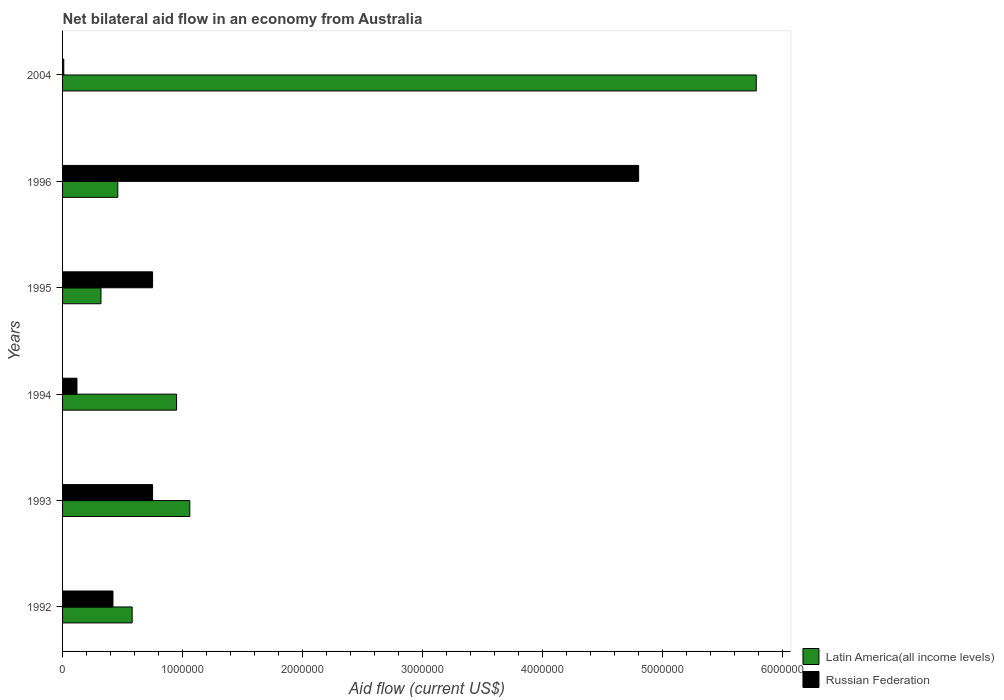How many different coloured bars are there?
Your response must be concise. 2. Are the number of bars per tick equal to the number of legend labels?
Provide a short and direct response. Yes. Are the number of bars on each tick of the Y-axis equal?
Ensure brevity in your answer.  Yes. How many bars are there on the 3rd tick from the top?
Your answer should be compact. 2. How many bars are there on the 3rd tick from the bottom?
Your response must be concise. 2. What is the label of the 1st group of bars from the top?
Provide a succinct answer. 2004. In how many cases, is the number of bars for a given year not equal to the number of legend labels?
Your answer should be compact. 0. What is the net bilateral aid flow in Russian Federation in 1992?
Make the answer very short. 4.20e+05. Across all years, what is the maximum net bilateral aid flow in Russian Federation?
Offer a terse response. 4.80e+06. Across all years, what is the minimum net bilateral aid flow in Latin America(all income levels)?
Offer a terse response. 3.20e+05. In which year was the net bilateral aid flow in Latin America(all income levels) minimum?
Keep it short and to the point. 1995. What is the total net bilateral aid flow in Russian Federation in the graph?
Make the answer very short. 6.85e+06. What is the difference between the net bilateral aid flow in Russian Federation in 1993 and that in 1994?
Your answer should be compact. 6.30e+05. What is the difference between the net bilateral aid flow in Latin America(all income levels) in 1993 and the net bilateral aid flow in Russian Federation in 1992?
Ensure brevity in your answer.  6.40e+05. What is the average net bilateral aid flow in Russian Federation per year?
Offer a very short reply. 1.14e+06. In the year 1996, what is the difference between the net bilateral aid flow in Russian Federation and net bilateral aid flow in Latin America(all income levels)?
Provide a short and direct response. 4.34e+06. What is the ratio of the net bilateral aid flow in Latin America(all income levels) in 1994 to that in 1995?
Give a very brief answer. 2.97. Is the net bilateral aid flow in Russian Federation in 1993 less than that in 1994?
Offer a terse response. No. Is the difference between the net bilateral aid flow in Russian Federation in 1995 and 1996 greater than the difference between the net bilateral aid flow in Latin America(all income levels) in 1995 and 1996?
Offer a very short reply. No. What is the difference between the highest and the second highest net bilateral aid flow in Latin America(all income levels)?
Offer a terse response. 4.72e+06. What is the difference between the highest and the lowest net bilateral aid flow in Latin America(all income levels)?
Make the answer very short. 5.46e+06. In how many years, is the net bilateral aid flow in Latin America(all income levels) greater than the average net bilateral aid flow in Latin America(all income levels) taken over all years?
Provide a short and direct response. 1. What does the 2nd bar from the top in 1992 represents?
Make the answer very short. Latin America(all income levels). What does the 1st bar from the bottom in 1994 represents?
Provide a short and direct response. Latin America(all income levels). How many bars are there?
Make the answer very short. 12. How many years are there in the graph?
Ensure brevity in your answer.  6. What is the difference between two consecutive major ticks on the X-axis?
Your answer should be very brief. 1.00e+06. Are the values on the major ticks of X-axis written in scientific E-notation?
Ensure brevity in your answer.  No. Does the graph contain any zero values?
Offer a terse response. No. Does the graph contain grids?
Your answer should be very brief. No. Where does the legend appear in the graph?
Make the answer very short. Bottom right. How many legend labels are there?
Make the answer very short. 2. What is the title of the graph?
Offer a terse response. Net bilateral aid flow in an economy from Australia. What is the label or title of the X-axis?
Make the answer very short. Aid flow (current US$). What is the Aid flow (current US$) of Latin America(all income levels) in 1992?
Provide a short and direct response. 5.80e+05. What is the Aid flow (current US$) of Russian Federation in 1992?
Make the answer very short. 4.20e+05. What is the Aid flow (current US$) in Latin America(all income levels) in 1993?
Give a very brief answer. 1.06e+06. What is the Aid flow (current US$) of Russian Federation in 1993?
Offer a terse response. 7.50e+05. What is the Aid flow (current US$) of Latin America(all income levels) in 1994?
Offer a terse response. 9.50e+05. What is the Aid flow (current US$) in Russian Federation in 1994?
Your answer should be compact. 1.20e+05. What is the Aid flow (current US$) of Russian Federation in 1995?
Make the answer very short. 7.50e+05. What is the Aid flow (current US$) of Latin America(all income levels) in 1996?
Your answer should be compact. 4.60e+05. What is the Aid flow (current US$) of Russian Federation in 1996?
Give a very brief answer. 4.80e+06. What is the Aid flow (current US$) of Latin America(all income levels) in 2004?
Provide a short and direct response. 5.78e+06. Across all years, what is the maximum Aid flow (current US$) in Latin America(all income levels)?
Provide a short and direct response. 5.78e+06. Across all years, what is the maximum Aid flow (current US$) of Russian Federation?
Your response must be concise. 4.80e+06. Across all years, what is the minimum Aid flow (current US$) in Latin America(all income levels)?
Give a very brief answer. 3.20e+05. Across all years, what is the minimum Aid flow (current US$) of Russian Federation?
Offer a very short reply. 10000. What is the total Aid flow (current US$) in Latin America(all income levels) in the graph?
Your answer should be very brief. 9.15e+06. What is the total Aid flow (current US$) of Russian Federation in the graph?
Provide a short and direct response. 6.85e+06. What is the difference between the Aid flow (current US$) of Latin America(all income levels) in 1992 and that in 1993?
Offer a very short reply. -4.80e+05. What is the difference between the Aid flow (current US$) in Russian Federation in 1992 and that in 1993?
Provide a succinct answer. -3.30e+05. What is the difference between the Aid flow (current US$) of Latin America(all income levels) in 1992 and that in 1994?
Offer a very short reply. -3.70e+05. What is the difference between the Aid flow (current US$) in Latin America(all income levels) in 1992 and that in 1995?
Offer a terse response. 2.60e+05. What is the difference between the Aid flow (current US$) in Russian Federation in 1992 and that in 1995?
Provide a short and direct response. -3.30e+05. What is the difference between the Aid flow (current US$) in Russian Federation in 1992 and that in 1996?
Give a very brief answer. -4.38e+06. What is the difference between the Aid flow (current US$) in Latin America(all income levels) in 1992 and that in 2004?
Give a very brief answer. -5.20e+06. What is the difference between the Aid flow (current US$) in Latin America(all income levels) in 1993 and that in 1994?
Keep it short and to the point. 1.10e+05. What is the difference between the Aid flow (current US$) of Russian Federation in 1993 and that in 1994?
Make the answer very short. 6.30e+05. What is the difference between the Aid flow (current US$) of Latin America(all income levels) in 1993 and that in 1995?
Ensure brevity in your answer.  7.40e+05. What is the difference between the Aid flow (current US$) of Russian Federation in 1993 and that in 1996?
Provide a short and direct response. -4.05e+06. What is the difference between the Aid flow (current US$) of Latin America(all income levels) in 1993 and that in 2004?
Your answer should be compact. -4.72e+06. What is the difference between the Aid flow (current US$) in Russian Federation in 1993 and that in 2004?
Your answer should be very brief. 7.40e+05. What is the difference between the Aid flow (current US$) in Latin America(all income levels) in 1994 and that in 1995?
Give a very brief answer. 6.30e+05. What is the difference between the Aid flow (current US$) in Russian Federation in 1994 and that in 1995?
Offer a very short reply. -6.30e+05. What is the difference between the Aid flow (current US$) of Russian Federation in 1994 and that in 1996?
Keep it short and to the point. -4.68e+06. What is the difference between the Aid flow (current US$) in Latin America(all income levels) in 1994 and that in 2004?
Provide a succinct answer. -4.83e+06. What is the difference between the Aid flow (current US$) of Russian Federation in 1994 and that in 2004?
Offer a very short reply. 1.10e+05. What is the difference between the Aid flow (current US$) in Russian Federation in 1995 and that in 1996?
Offer a terse response. -4.05e+06. What is the difference between the Aid flow (current US$) in Latin America(all income levels) in 1995 and that in 2004?
Your answer should be very brief. -5.46e+06. What is the difference between the Aid flow (current US$) of Russian Federation in 1995 and that in 2004?
Your response must be concise. 7.40e+05. What is the difference between the Aid flow (current US$) in Latin America(all income levels) in 1996 and that in 2004?
Your answer should be very brief. -5.32e+06. What is the difference between the Aid flow (current US$) of Russian Federation in 1996 and that in 2004?
Offer a terse response. 4.79e+06. What is the difference between the Aid flow (current US$) of Latin America(all income levels) in 1992 and the Aid flow (current US$) of Russian Federation in 1994?
Keep it short and to the point. 4.60e+05. What is the difference between the Aid flow (current US$) of Latin America(all income levels) in 1992 and the Aid flow (current US$) of Russian Federation in 1995?
Your answer should be very brief. -1.70e+05. What is the difference between the Aid flow (current US$) in Latin America(all income levels) in 1992 and the Aid flow (current US$) in Russian Federation in 1996?
Offer a very short reply. -4.22e+06. What is the difference between the Aid flow (current US$) in Latin America(all income levels) in 1992 and the Aid flow (current US$) in Russian Federation in 2004?
Make the answer very short. 5.70e+05. What is the difference between the Aid flow (current US$) of Latin America(all income levels) in 1993 and the Aid flow (current US$) of Russian Federation in 1994?
Give a very brief answer. 9.40e+05. What is the difference between the Aid flow (current US$) of Latin America(all income levels) in 1993 and the Aid flow (current US$) of Russian Federation in 1995?
Keep it short and to the point. 3.10e+05. What is the difference between the Aid flow (current US$) of Latin America(all income levels) in 1993 and the Aid flow (current US$) of Russian Federation in 1996?
Give a very brief answer. -3.74e+06. What is the difference between the Aid flow (current US$) of Latin America(all income levels) in 1993 and the Aid flow (current US$) of Russian Federation in 2004?
Your answer should be compact. 1.05e+06. What is the difference between the Aid flow (current US$) in Latin America(all income levels) in 1994 and the Aid flow (current US$) in Russian Federation in 1996?
Provide a succinct answer. -3.85e+06. What is the difference between the Aid flow (current US$) of Latin America(all income levels) in 1994 and the Aid flow (current US$) of Russian Federation in 2004?
Offer a very short reply. 9.40e+05. What is the difference between the Aid flow (current US$) in Latin America(all income levels) in 1995 and the Aid flow (current US$) in Russian Federation in 1996?
Offer a terse response. -4.48e+06. What is the difference between the Aid flow (current US$) in Latin America(all income levels) in 1995 and the Aid flow (current US$) in Russian Federation in 2004?
Offer a terse response. 3.10e+05. What is the difference between the Aid flow (current US$) in Latin America(all income levels) in 1996 and the Aid flow (current US$) in Russian Federation in 2004?
Your response must be concise. 4.50e+05. What is the average Aid flow (current US$) of Latin America(all income levels) per year?
Make the answer very short. 1.52e+06. What is the average Aid flow (current US$) in Russian Federation per year?
Provide a short and direct response. 1.14e+06. In the year 1992, what is the difference between the Aid flow (current US$) in Latin America(all income levels) and Aid flow (current US$) in Russian Federation?
Your answer should be compact. 1.60e+05. In the year 1993, what is the difference between the Aid flow (current US$) in Latin America(all income levels) and Aid flow (current US$) in Russian Federation?
Offer a terse response. 3.10e+05. In the year 1994, what is the difference between the Aid flow (current US$) of Latin America(all income levels) and Aid flow (current US$) of Russian Federation?
Offer a terse response. 8.30e+05. In the year 1995, what is the difference between the Aid flow (current US$) in Latin America(all income levels) and Aid flow (current US$) in Russian Federation?
Keep it short and to the point. -4.30e+05. In the year 1996, what is the difference between the Aid flow (current US$) in Latin America(all income levels) and Aid flow (current US$) in Russian Federation?
Your answer should be very brief. -4.34e+06. In the year 2004, what is the difference between the Aid flow (current US$) in Latin America(all income levels) and Aid flow (current US$) in Russian Federation?
Make the answer very short. 5.77e+06. What is the ratio of the Aid flow (current US$) in Latin America(all income levels) in 1992 to that in 1993?
Your response must be concise. 0.55. What is the ratio of the Aid flow (current US$) in Russian Federation in 1992 to that in 1993?
Ensure brevity in your answer.  0.56. What is the ratio of the Aid flow (current US$) of Latin America(all income levels) in 1992 to that in 1994?
Provide a short and direct response. 0.61. What is the ratio of the Aid flow (current US$) in Russian Federation in 1992 to that in 1994?
Your answer should be very brief. 3.5. What is the ratio of the Aid flow (current US$) of Latin America(all income levels) in 1992 to that in 1995?
Offer a very short reply. 1.81. What is the ratio of the Aid flow (current US$) of Russian Federation in 1992 to that in 1995?
Keep it short and to the point. 0.56. What is the ratio of the Aid flow (current US$) of Latin America(all income levels) in 1992 to that in 1996?
Give a very brief answer. 1.26. What is the ratio of the Aid flow (current US$) of Russian Federation in 1992 to that in 1996?
Provide a short and direct response. 0.09. What is the ratio of the Aid flow (current US$) in Latin America(all income levels) in 1992 to that in 2004?
Provide a succinct answer. 0.1. What is the ratio of the Aid flow (current US$) of Latin America(all income levels) in 1993 to that in 1994?
Provide a short and direct response. 1.12. What is the ratio of the Aid flow (current US$) in Russian Federation in 1993 to that in 1994?
Provide a succinct answer. 6.25. What is the ratio of the Aid flow (current US$) in Latin America(all income levels) in 1993 to that in 1995?
Provide a short and direct response. 3.31. What is the ratio of the Aid flow (current US$) of Latin America(all income levels) in 1993 to that in 1996?
Your answer should be very brief. 2.3. What is the ratio of the Aid flow (current US$) of Russian Federation in 1993 to that in 1996?
Offer a very short reply. 0.16. What is the ratio of the Aid flow (current US$) of Latin America(all income levels) in 1993 to that in 2004?
Your answer should be compact. 0.18. What is the ratio of the Aid flow (current US$) of Russian Federation in 1993 to that in 2004?
Ensure brevity in your answer.  75. What is the ratio of the Aid flow (current US$) in Latin America(all income levels) in 1994 to that in 1995?
Provide a short and direct response. 2.97. What is the ratio of the Aid flow (current US$) in Russian Federation in 1994 to that in 1995?
Your answer should be compact. 0.16. What is the ratio of the Aid flow (current US$) of Latin America(all income levels) in 1994 to that in 1996?
Your answer should be very brief. 2.07. What is the ratio of the Aid flow (current US$) of Russian Federation in 1994 to that in 1996?
Provide a short and direct response. 0.03. What is the ratio of the Aid flow (current US$) in Latin America(all income levels) in 1994 to that in 2004?
Ensure brevity in your answer.  0.16. What is the ratio of the Aid flow (current US$) of Latin America(all income levels) in 1995 to that in 1996?
Your answer should be compact. 0.7. What is the ratio of the Aid flow (current US$) in Russian Federation in 1995 to that in 1996?
Give a very brief answer. 0.16. What is the ratio of the Aid flow (current US$) of Latin America(all income levels) in 1995 to that in 2004?
Offer a terse response. 0.06. What is the ratio of the Aid flow (current US$) in Russian Federation in 1995 to that in 2004?
Your response must be concise. 75. What is the ratio of the Aid flow (current US$) of Latin America(all income levels) in 1996 to that in 2004?
Ensure brevity in your answer.  0.08. What is the ratio of the Aid flow (current US$) in Russian Federation in 1996 to that in 2004?
Your answer should be very brief. 480. What is the difference between the highest and the second highest Aid flow (current US$) in Latin America(all income levels)?
Offer a terse response. 4.72e+06. What is the difference between the highest and the second highest Aid flow (current US$) in Russian Federation?
Your answer should be very brief. 4.05e+06. What is the difference between the highest and the lowest Aid flow (current US$) in Latin America(all income levels)?
Keep it short and to the point. 5.46e+06. What is the difference between the highest and the lowest Aid flow (current US$) in Russian Federation?
Keep it short and to the point. 4.79e+06. 